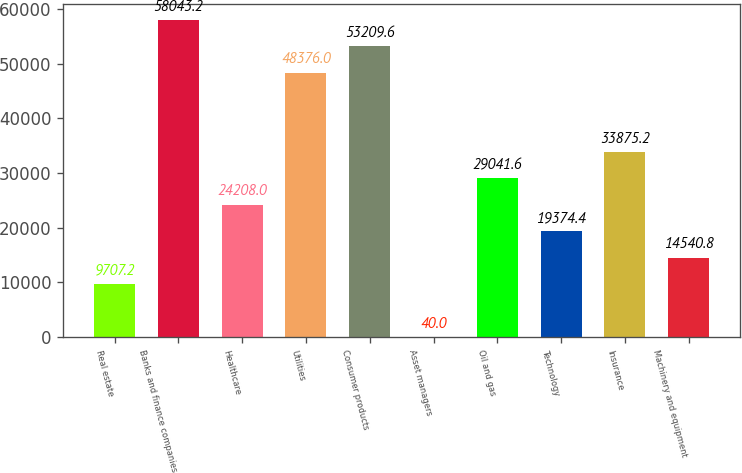Convert chart. <chart><loc_0><loc_0><loc_500><loc_500><bar_chart><fcel>Real estate<fcel>Banks and finance companies<fcel>Healthcare<fcel>Utilities<fcel>Consumer products<fcel>Asset managers<fcel>Oil and gas<fcel>Technology<fcel>Insurance<fcel>Machinery and equipment<nl><fcel>9707.2<fcel>58043.2<fcel>24208<fcel>48376<fcel>53209.6<fcel>40<fcel>29041.6<fcel>19374.4<fcel>33875.2<fcel>14540.8<nl></chart> 